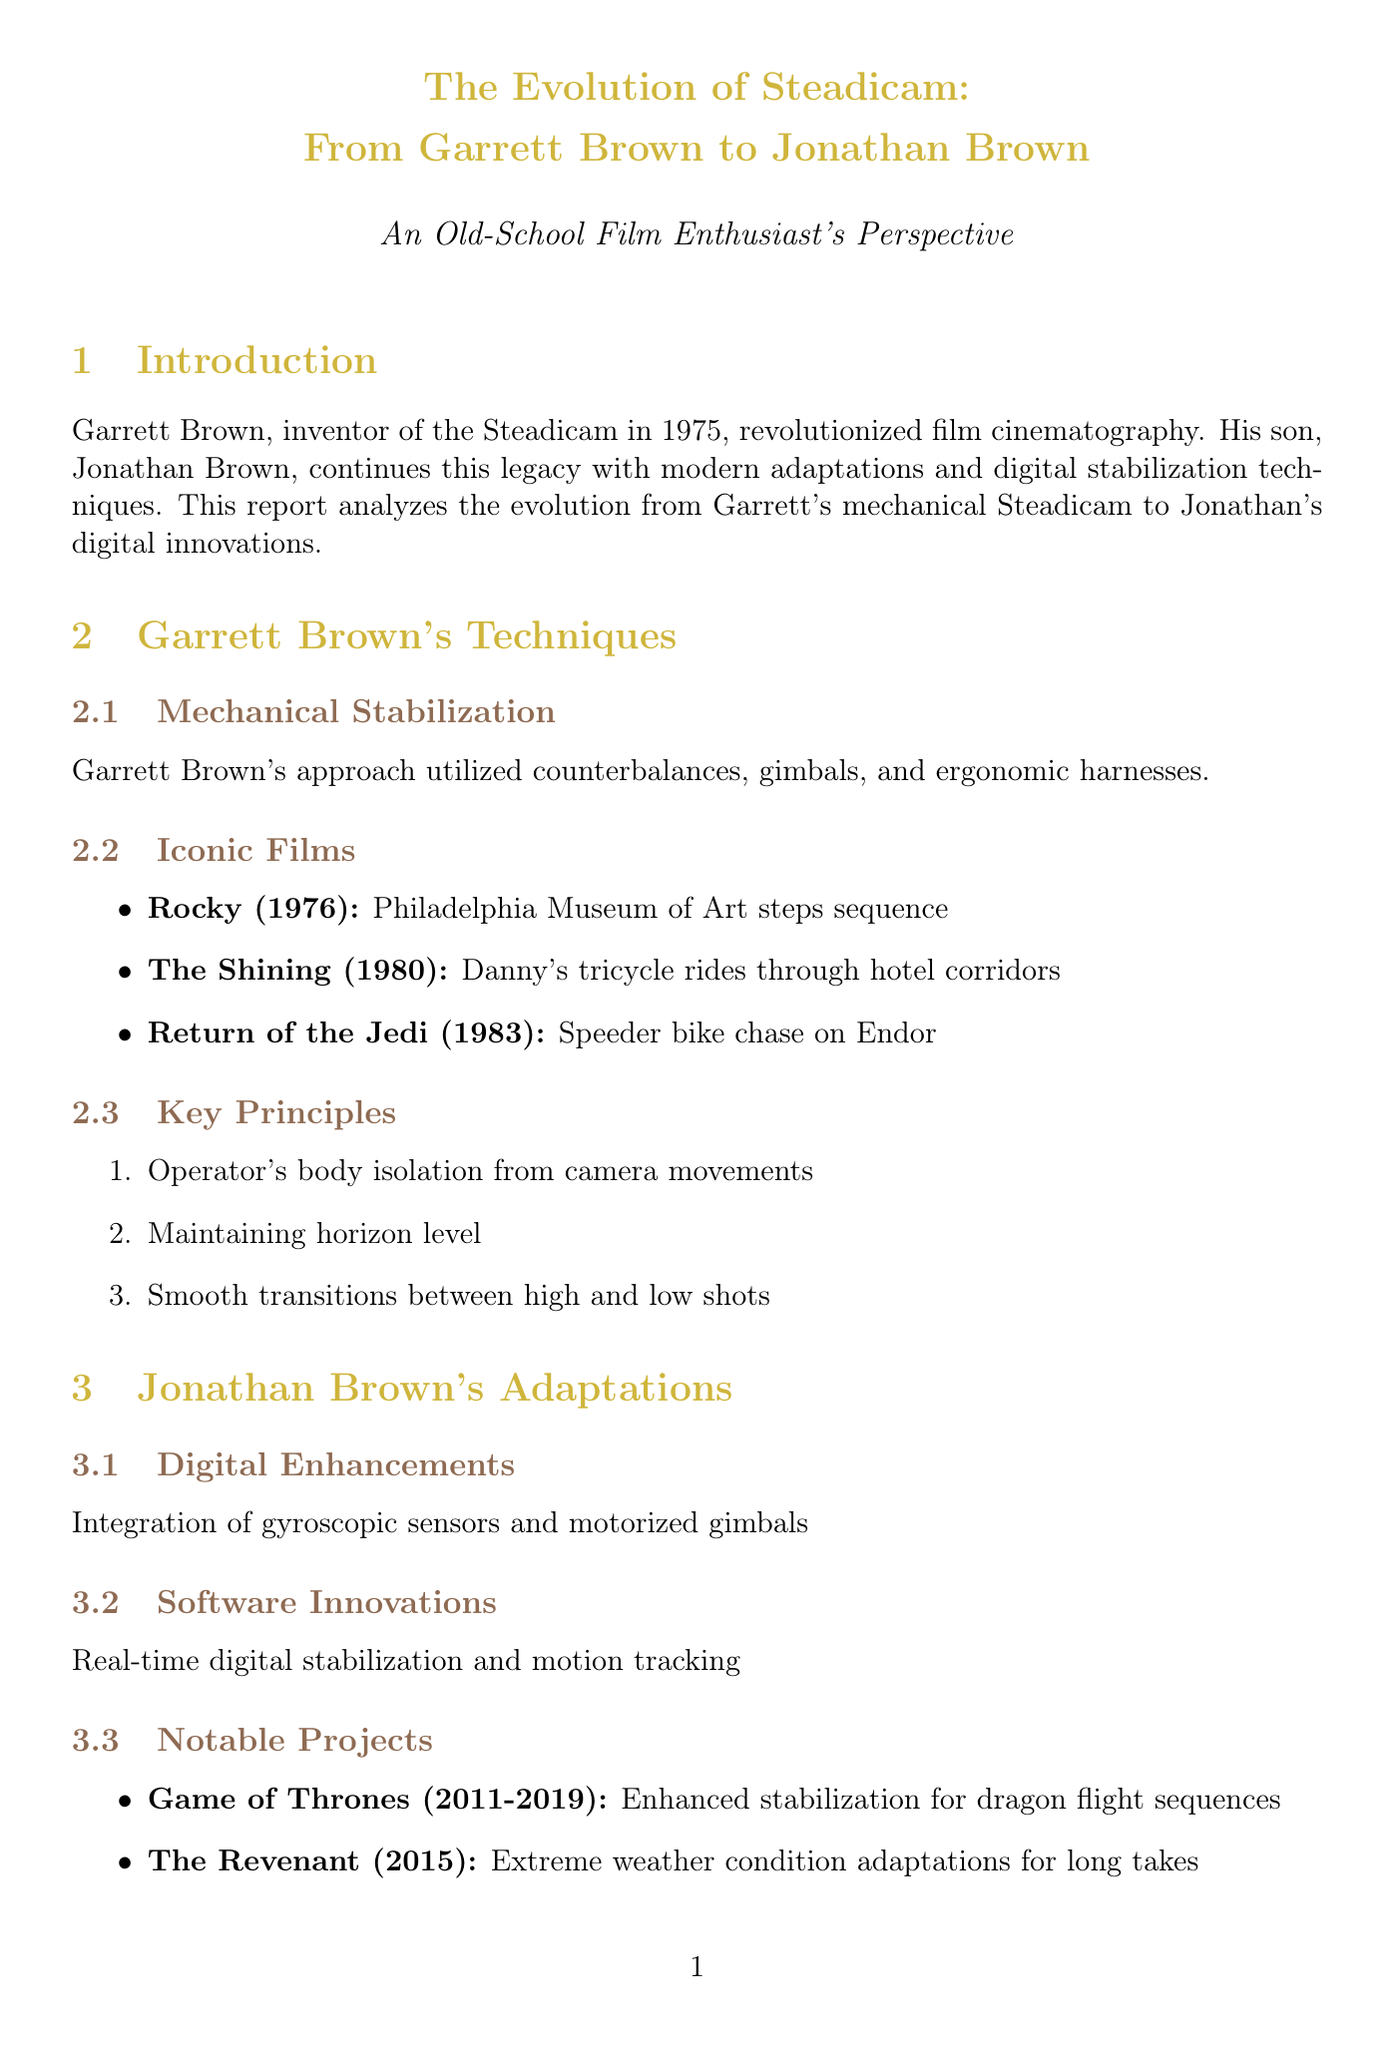What is the year Garrett Brown invented the Steadicam? The document states that Garrett Brown invented the Steadicam in 1975.
Answer: 1975 In which film is the notable scene "Philadelphia Museum of Art steps sequence"? The notable scene is from the film "Rocky," which was released in 1976.
Answer: Rocky What technology does Jonathan Brown integrate for modern adaptations? According to the document, Jonathan Brown integrates gyroscopic sensors and motorized gimbals.
Answer: Gyroscopic sensors and motorized gimbals What is a key principle of Garrett Brown's techniques? One of the key principles listed is "Operator's body isolation from camera movements."
Answer: Operator's body isolation from camera movements Which notable project features enhanced stabilization for dragon flight sequences? The document mentions that "Game of Thrones" features enhanced stabilization for dragon flight sequences.
Answer: Game of Thrones How many case studies are presented in the document? The document outlines two case studies: "Birdman" and "1917."
Answer: Two What major advancement does Jonathan Brown's equipment offer compared to Garrett's? The advancement mentioned is that Jonathan's equipment is typically lighter for increased mobility.
Answer: Lighter equipment Who was the cinematographer for the film "Birdman"? The document states that Emmanuel Lubezki was the cinematographer for "Birdman."
Answer: Emmanuel Lubezki What emerging technology is proposed for future filmmaking? The document discusses AI-driven stabilization algorithms as an emerging technology.
Answer: AI-driven stabilization algorithms 